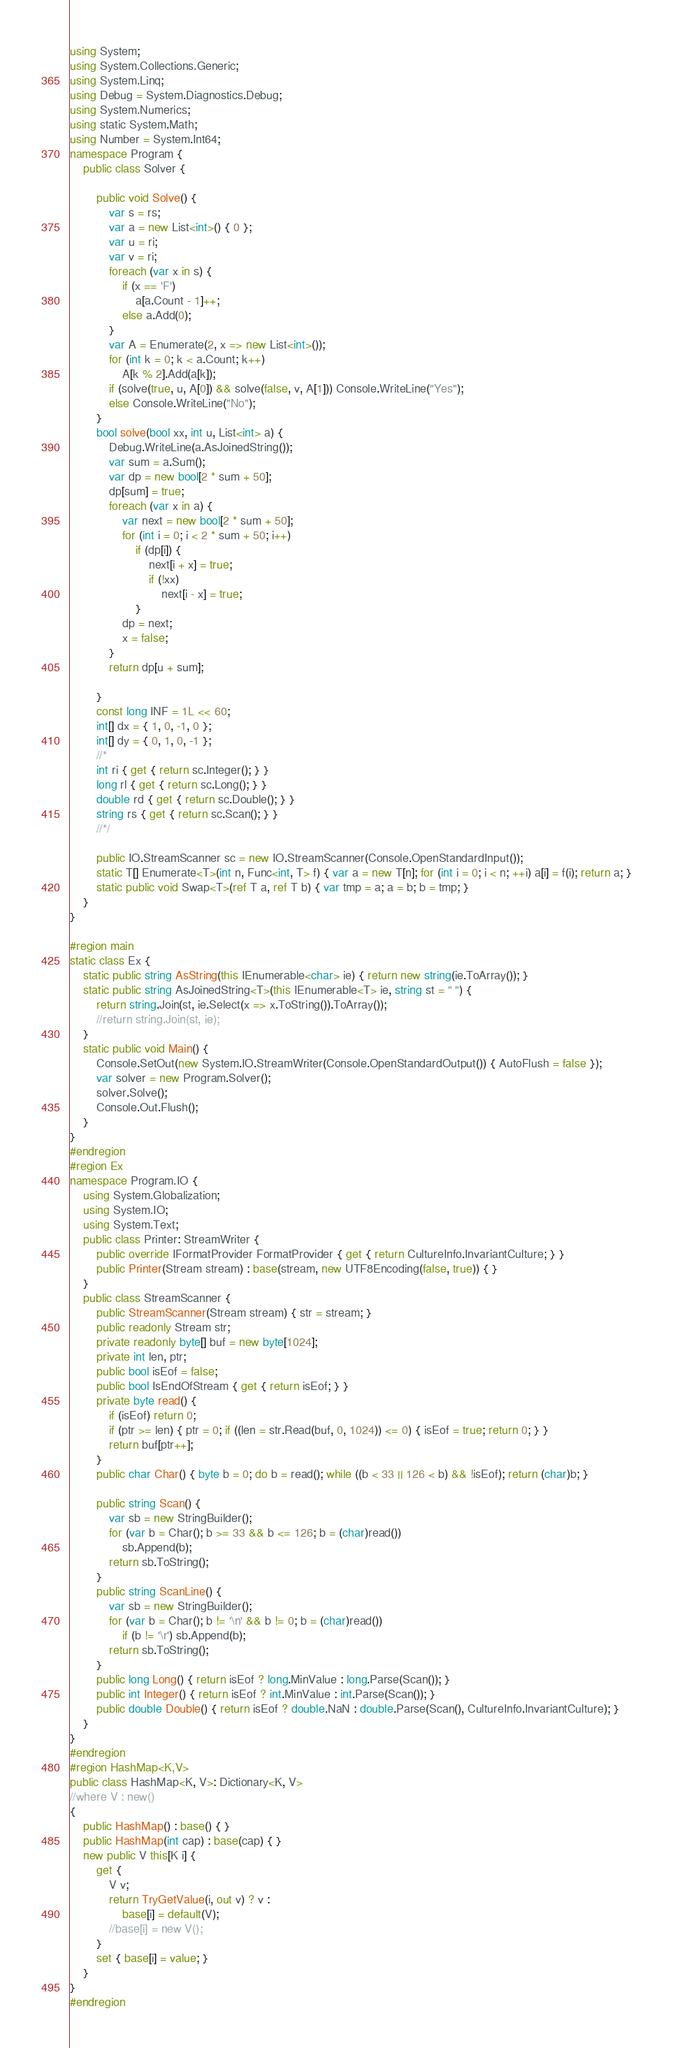<code> <loc_0><loc_0><loc_500><loc_500><_C#_>using System;
using System.Collections.Generic;
using System.Linq;
using Debug = System.Diagnostics.Debug;
using System.Numerics;
using static System.Math;
using Number = System.Int64;
namespace Program {
    public class Solver {

        public void Solve() {
            var s = rs;
            var a = new List<int>() { 0 };
            var u = ri;
            var v = ri;
            foreach (var x in s) {
                if (x == 'F')
                    a[a.Count - 1]++;
                else a.Add(0);
            }
            var A = Enumerate(2, x => new List<int>());
            for (int k = 0; k < a.Count; k++)
                A[k % 2].Add(a[k]);
            if (solve(true, u, A[0]) && solve(false, v, A[1])) Console.WriteLine("Yes");
            else Console.WriteLine("No");
        }
        bool solve(bool xx, int u, List<int> a) {
            Debug.WriteLine(a.AsJoinedString());
            var sum = a.Sum();
            var dp = new bool[2 * sum + 50];
            dp[sum] = true;
            foreach (var x in a) {
                var next = new bool[2 * sum + 50];
                for (int i = 0; i < 2 * sum + 50; i++)
                    if (dp[i]) {
                        next[i + x] = true;
                        if (!xx)
                            next[i - x] = true;
                    }
                dp = next;
                x = false;
            }
            return dp[u + sum];

        }
        const long INF = 1L << 60;
        int[] dx = { 1, 0, -1, 0 };
        int[] dy = { 0, 1, 0, -1 };
        //*
        int ri { get { return sc.Integer(); } }
        long rl { get { return sc.Long(); } }
        double rd { get { return sc.Double(); } }
        string rs { get { return sc.Scan(); } }
        //*/

        public IO.StreamScanner sc = new IO.StreamScanner(Console.OpenStandardInput());
        static T[] Enumerate<T>(int n, Func<int, T> f) { var a = new T[n]; for (int i = 0; i < n; ++i) a[i] = f(i); return a; }
        static public void Swap<T>(ref T a, ref T b) { var tmp = a; a = b; b = tmp; }
    }
}

#region main
static class Ex {
    static public string AsString(this IEnumerable<char> ie) { return new string(ie.ToArray()); }
    static public string AsJoinedString<T>(this IEnumerable<T> ie, string st = " ") {
        return string.Join(st, ie.Select(x => x.ToString()).ToArray());
        //return string.Join(st, ie);
    }
    static public void Main() {
        Console.SetOut(new System.IO.StreamWriter(Console.OpenStandardOutput()) { AutoFlush = false });
        var solver = new Program.Solver();
        solver.Solve();
        Console.Out.Flush();
    }
}
#endregion
#region Ex
namespace Program.IO {
    using System.Globalization;
    using System.IO;
    using System.Text;
    public class Printer: StreamWriter {
        public override IFormatProvider FormatProvider { get { return CultureInfo.InvariantCulture; } }
        public Printer(Stream stream) : base(stream, new UTF8Encoding(false, true)) { }
    }
    public class StreamScanner {
        public StreamScanner(Stream stream) { str = stream; }
        public readonly Stream str;
        private readonly byte[] buf = new byte[1024];
        private int len, ptr;
        public bool isEof = false;
        public bool IsEndOfStream { get { return isEof; } }
        private byte read() {
            if (isEof) return 0;
            if (ptr >= len) { ptr = 0; if ((len = str.Read(buf, 0, 1024)) <= 0) { isEof = true; return 0; } }
            return buf[ptr++];
        }
        public char Char() { byte b = 0; do b = read(); while ((b < 33 || 126 < b) && !isEof); return (char)b; }

        public string Scan() {
            var sb = new StringBuilder();
            for (var b = Char(); b >= 33 && b <= 126; b = (char)read())
                sb.Append(b);
            return sb.ToString();
        }
        public string ScanLine() {
            var sb = new StringBuilder();
            for (var b = Char(); b != '\n' && b != 0; b = (char)read())
                if (b != '\r') sb.Append(b);
            return sb.ToString();
        }
        public long Long() { return isEof ? long.MinValue : long.Parse(Scan()); }
        public int Integer() { return isEof ? int.MinValue : int.Parse(Scan()); }
        public double Double() { return isEof ? double.NaN : double.Parse(Scan(), CultureInfo.InvariantCulture); }
    }
}
#endregion
#region HashMap<K,V>
public class HashMap<K, V>: Dictionary<K, V>
//where V : new()
{
    public HashMap() : base() { }
    public HashMap(int cap) : base(cap) { }
    new public V this[K i] {
        get {
            V v;
            return TryGetValue(i, out v) ? v :
                base[i] = default(V);
            //base[i] = new V();
        }
        set { base[i] = value; }
    }
}
#endregion</code> 